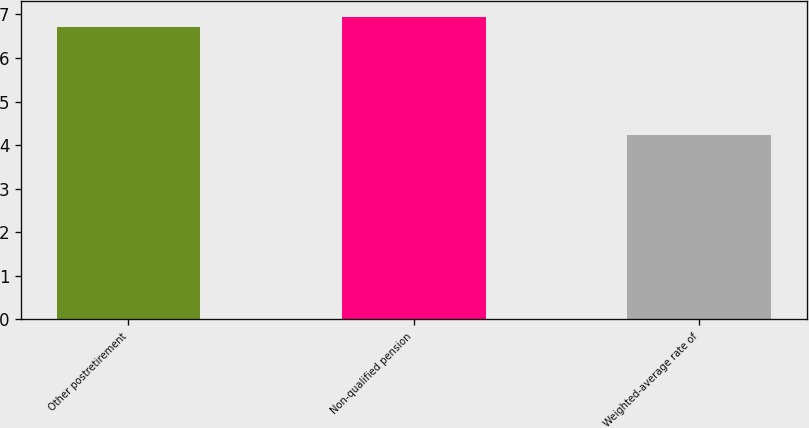Convert chart. <chart><loc_0><loc_0><loc_500><loc_500><bar_chart><fcel>Other postretirement<fcel>Non-qualified pension<fcel>Weighted-average rate of<nl><fcel>6.7<fcel>6.95<fcel>4.23<nl></chart> 